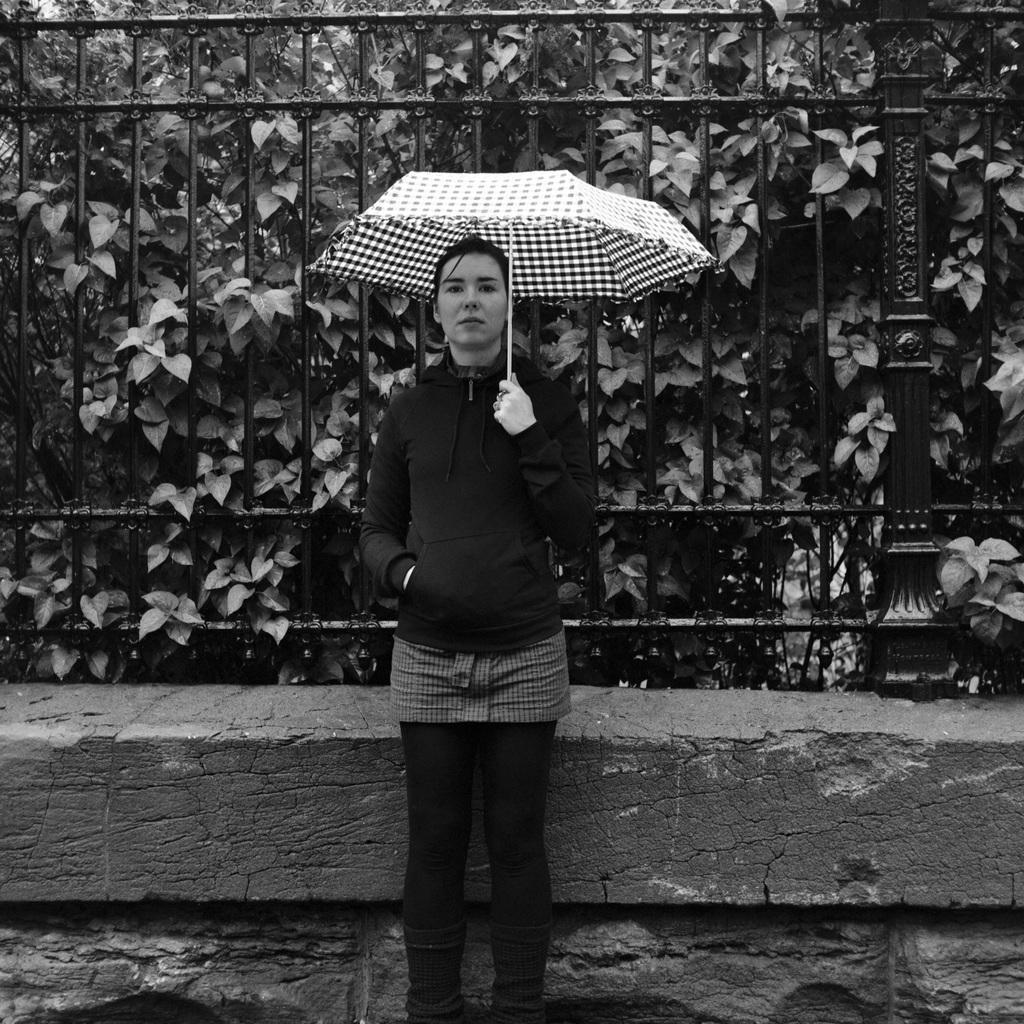Could you give a brief overview of what you see in this image? In the middle of the image we can see a woman, she is holding an umbrella, behind to her we can see few metal rods and trees, and it is a black and white photography. 